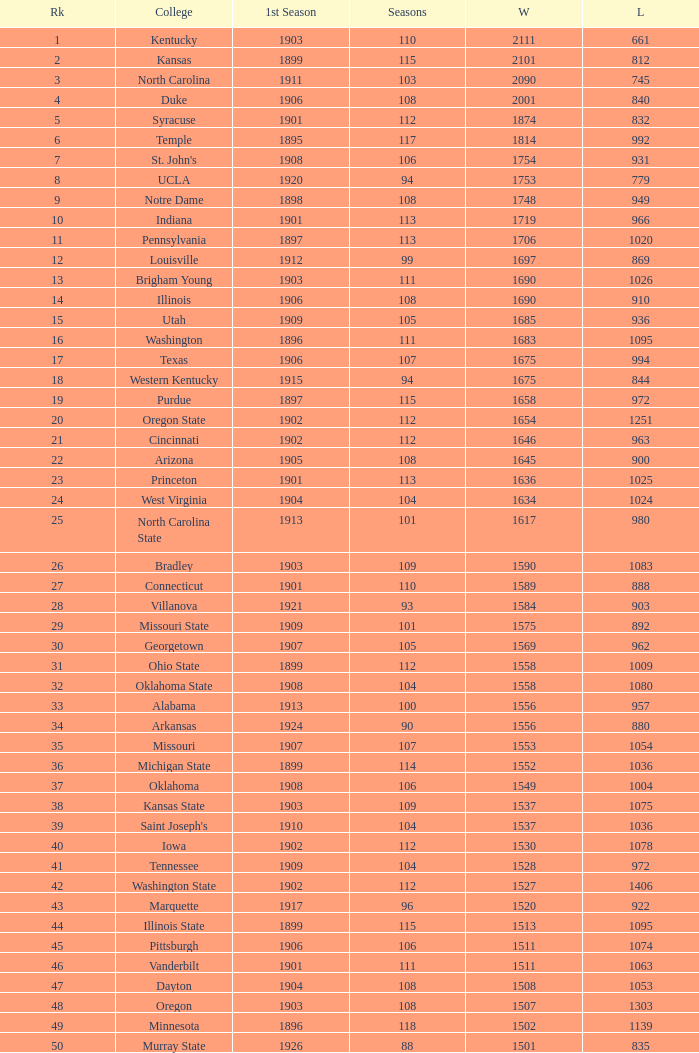What is the total of First Season games with 1537 Wins and a Season greater than 109? None. 